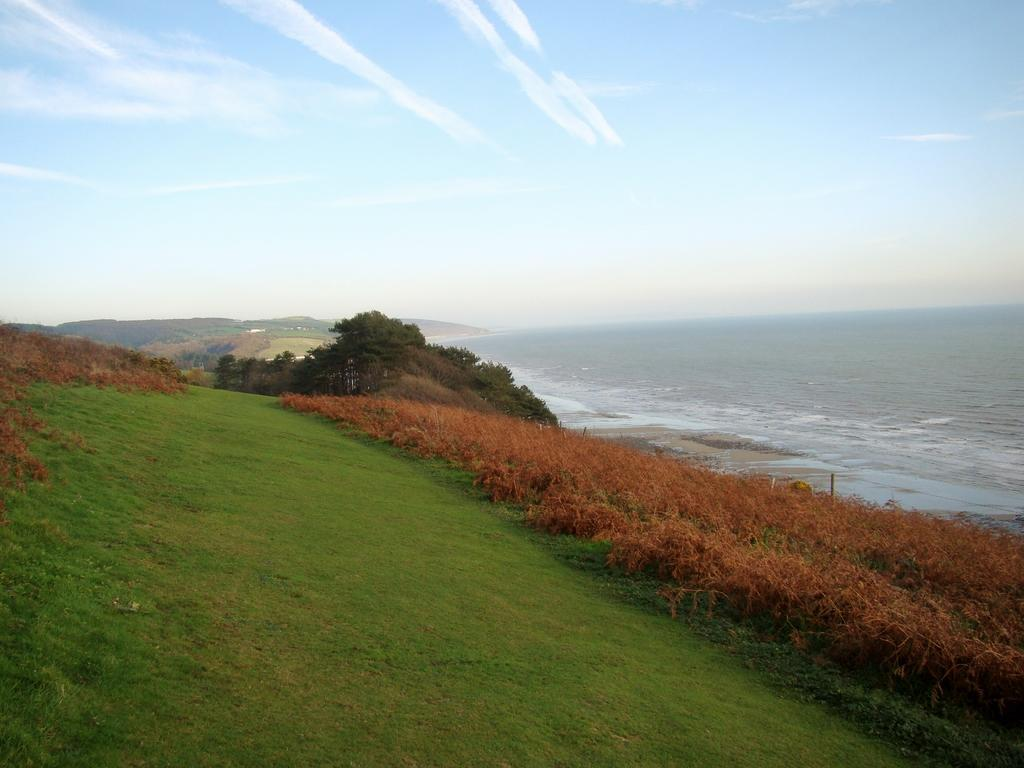What is the primary element visible in the image? There is water in the image. What other natural elements can be seen in the image? There are plants, trees, and grass on the ground in the image. What is visible at the top of the image? The sky is visible at the top of the image. What type of insurance policy is being discussed in the image? There is no discussion of insurance policies in the image; it features water, plants, trees, grass, and the sky. 